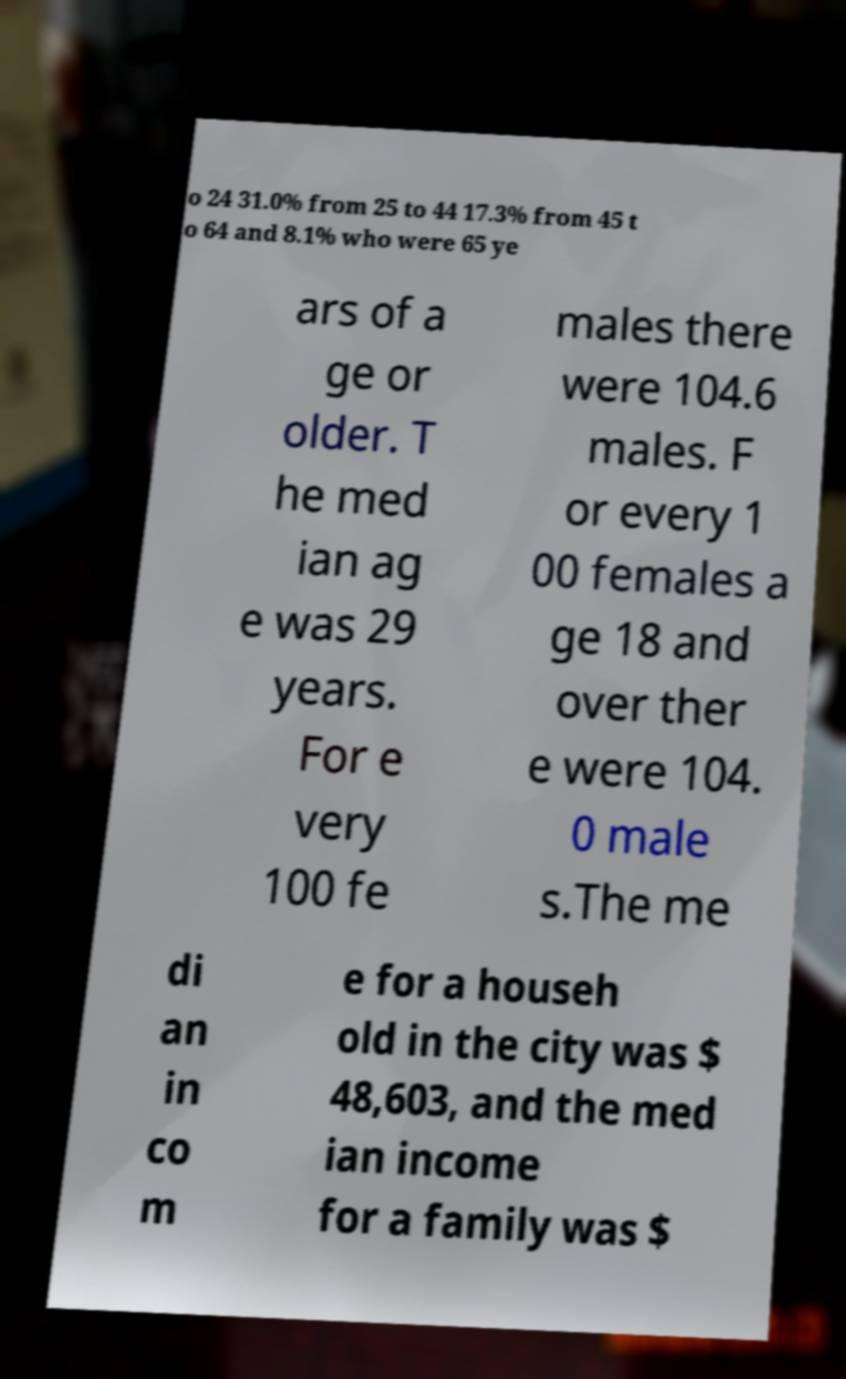Please identify and transcribe the text found in this image. o 24 31.0% from 25 to 44 17.3% from 45 t o 64 and 8.1% who were 65 ye ars of a ge or older. T he med ian ag e was 29 years. For e very 100 fe males there were 104.6 males. F or every 1 00 females a ge 18 and over ther e were 104. 0 male s.The me di an in co m e for a househ old in the city was $ 48,603, and the med ian income for a family was $ 